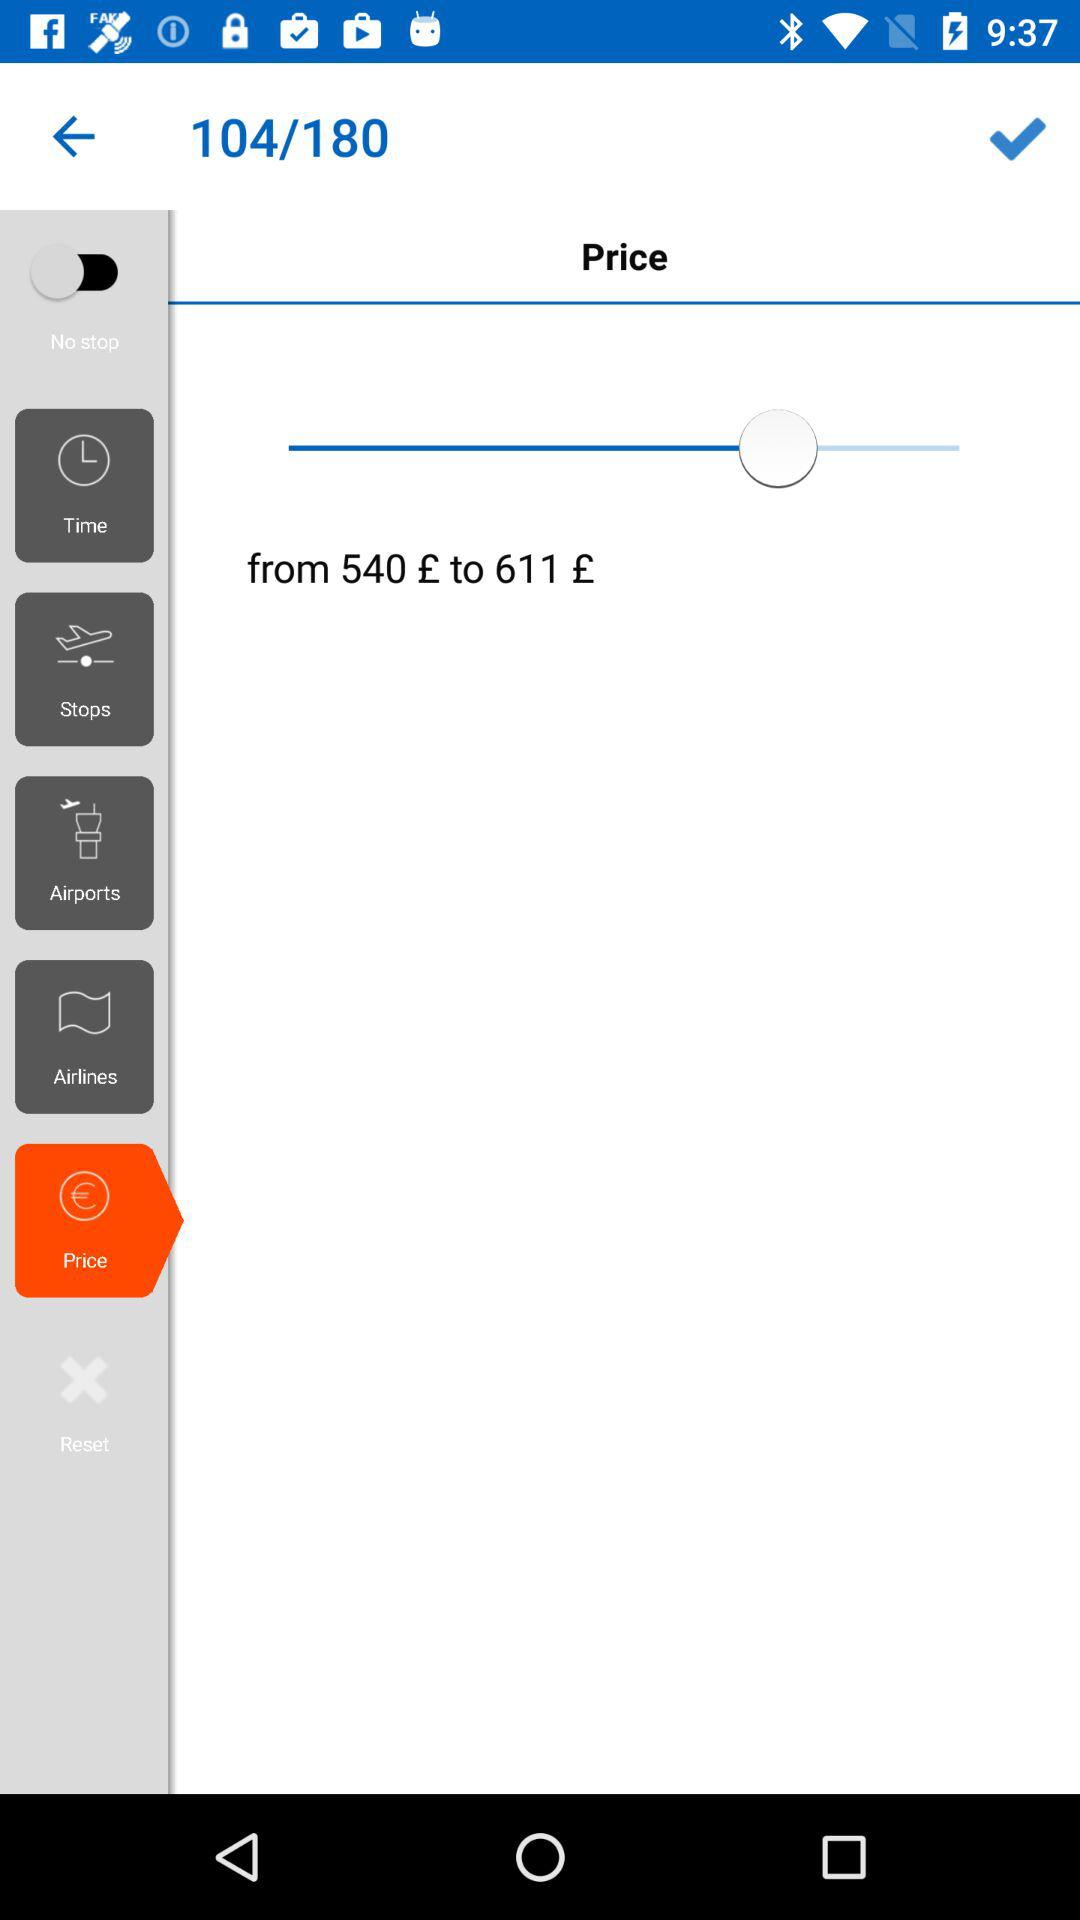What will be the flight price? The flight price will range from €540 to €611. 